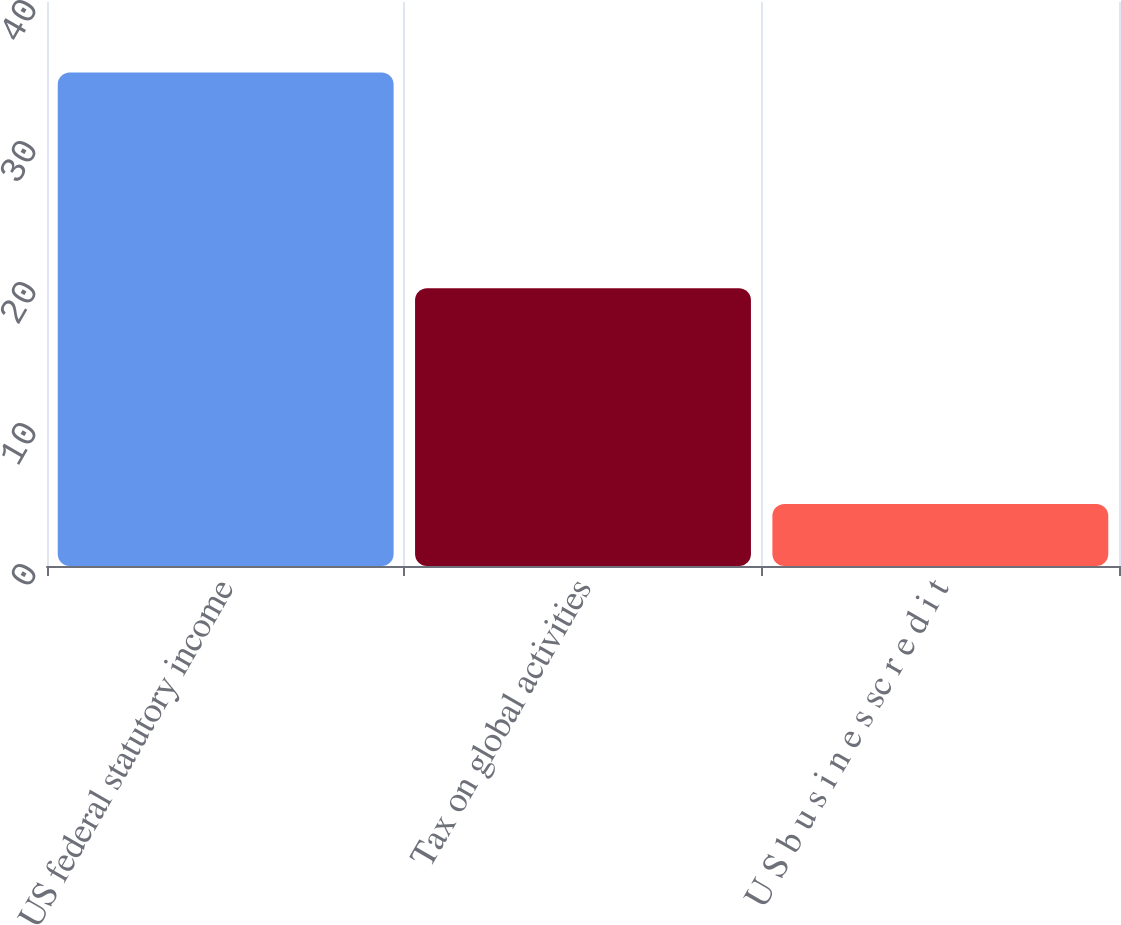Convert chart to OTSL. <chart><loc_0><loc_0><loc_500><loc_500><bar_chart><fcel>US federal statutory income<fcel>Tax on global activities<fcel>U S b u s i n e s sc r e d i t<nl><fcel>35<fcel>19.7<fcel>4.4<nl></chart> 